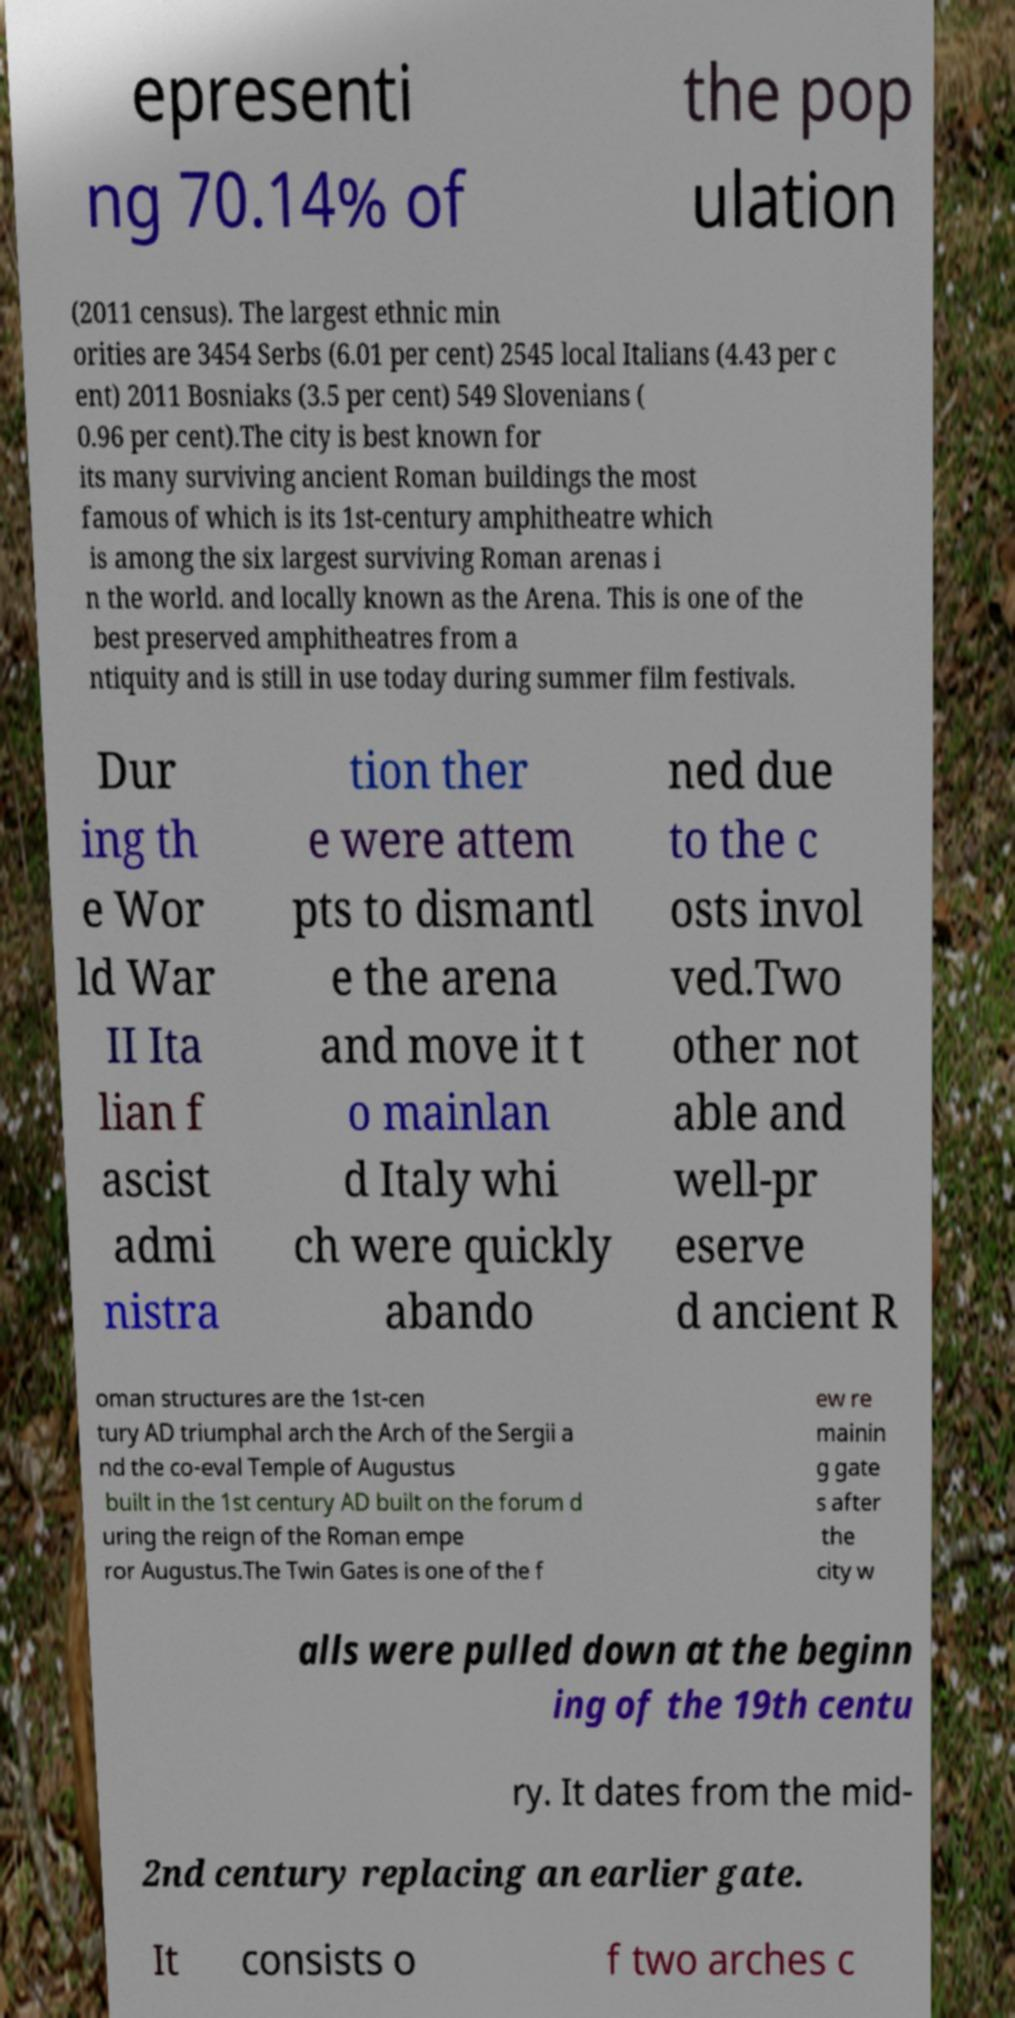What messages or text are displayed in this image? I need them in a readable, typed format. epresenti ng 70.14% of the pop ulation (2011 census). The largest ethnic min orities are 3454 Serbs (6.01 per cent) 2545 local Italians (4.43 per c ent) 2011 Bosniaks (3.5 per cent) 549 Slovenians ( 0.96 per cent).The city is best known for its many surviving ancient Roman buildings the most famous of which is its 1st-century amphitheatre which is among the six largest surviving Roman arenas i n the world. and locally known as the Arena. This is one of the best preserved amphitheatres from a ntiquity and is still in use today during summer film festivals. Dur ing th e Wor ld War II Ita lian f ascist admi nistra tion ther e were attem pts to dismantl e the arena and move it t o mainlan d Italy whi ch were quickly abando ned due to the c osts invol ved.Two other not able and well-pr eserve d ancient R oman structures are the 1st-cen tury AD triumphal arch the Arch of the Sergii a nd the co-eval Temple of Augustus built in the 1st century AD built on the forum d uring the reign of the Roman empe ror Augustus.The Twin Gates is one of the f ew re mainin g gate s after the city w alls were pulled down at the beginn ing of the 19th centu ry. It dates from the mid- 2nd century replacing an earlier gate. It consists o f two arches c 